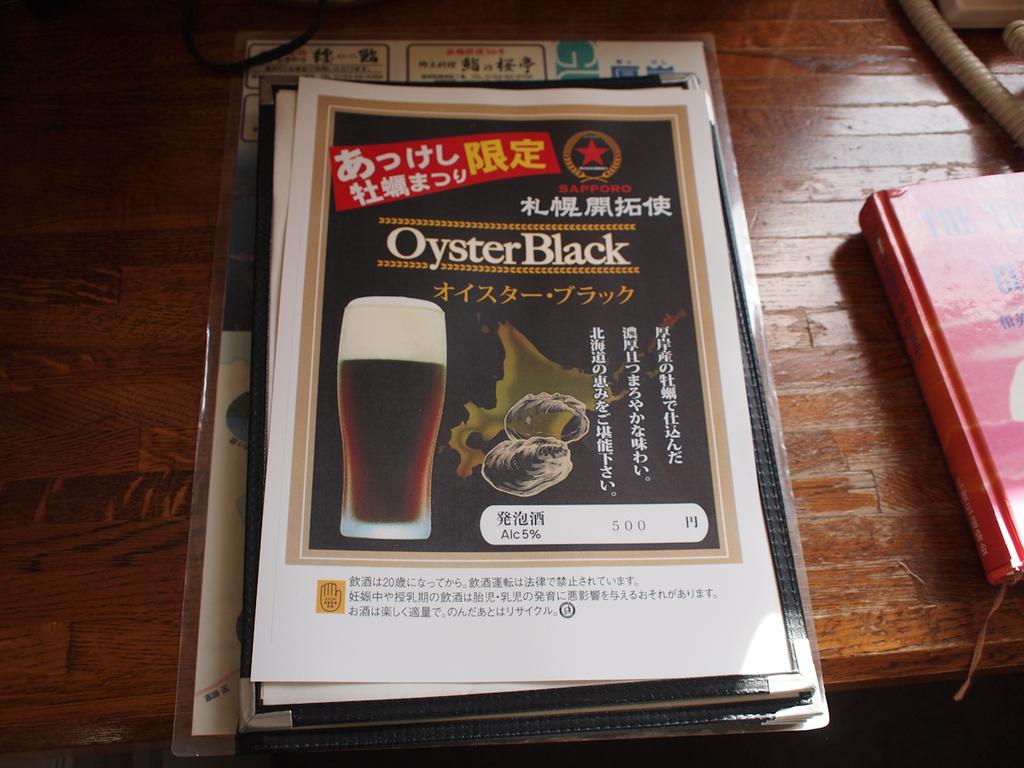What is the brand of the beverage on the flyer?
Provide a short and direct response. Oyster black. What color are the letters of the brand name?
Give a very brief answer. White. 